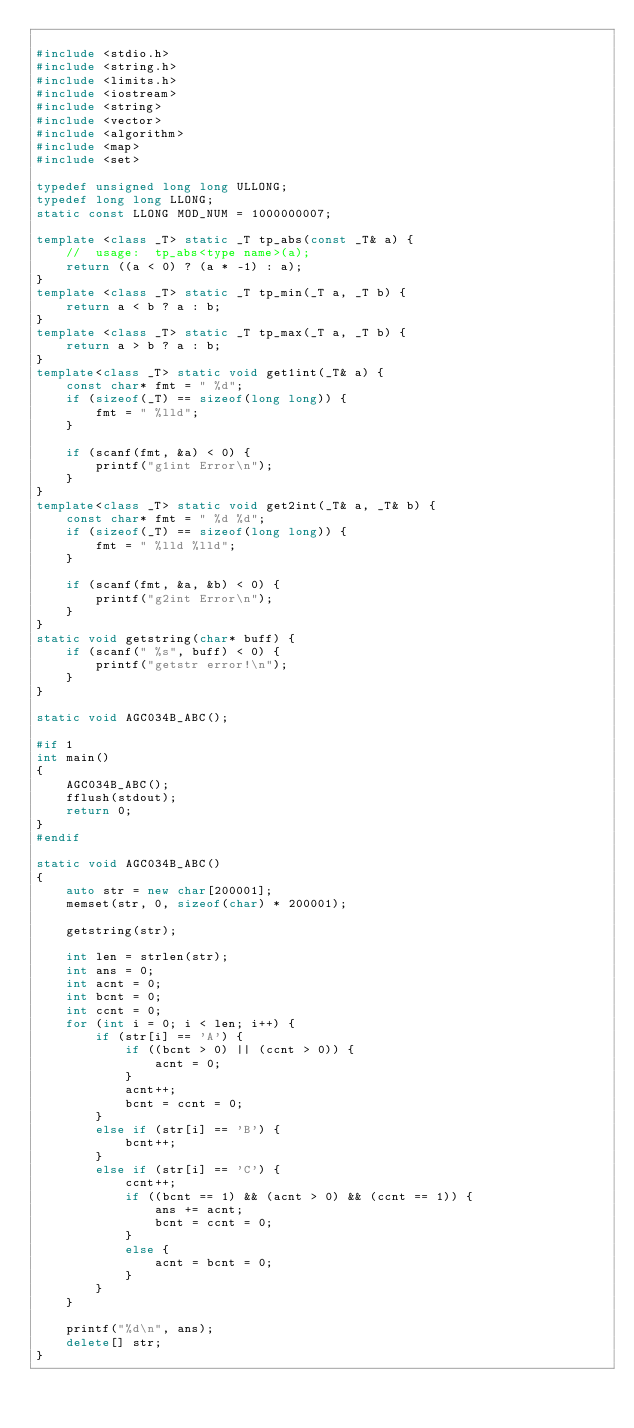<code> <loc_0><loc_0><loc_500><loc_500><_C++_>
#include <stdio.h>
#include <string.h>
#include <limits.h>
#include <iostream>
#include <string>
#include <vector>
#include <algorithm>
#include <map>
#include <set>

typedef unsigned long long ULLONG;
typedef long long LLONG;
static const LLONG MOD_NUM = 1000000007;

template <class _T> static _T tp_abs(const _T& a) {
	//	usage:  tp_abs<type name>(a);
	return ((a < 0) ? (a * -1) : a);
}
template <class _T> static _T tp_min(_T a, _T b) {
	return a < b ? a : b;
}
template <class _T> static _T tp_max(_T a, _T b) {
	return a > b ? a : b;
}
template<class _T> static void get1int(_T& a) {
	const char* fmt = " %d";
	if (sizeof(_T) == sizeof(long long)) {
		fmt = " %lld";
	}

	if (scanf(fmt, &a) < 0) {
		printf("g1int Error\n");
	}
}
template<class _T> static void get2int(_T& a, _T& b) {
	const char* fmt = " %d %d";
	if (sizeof(_T) == sizeof(long long)) {
		fmt = " %lld %lld";
	}

	if (scanf(fmt, &a, &b) < 0) {
		printf("g2int Error\n");
	}
}
static void getstring(char* buff) {
	if (scanf(" %s", buff) < 0) {
		printf("getstr error!\n");
	}
}

static void AGC034B_ABC();

#if 1
int main()
{
	AGC034B_ABC();
	fflush(stdout);
	return 0;
}
#endif

static void AGC034B_ABC()
{
	auto str = new char[200001];
	memset(str, 0, sizeof(char) * 200001);

	getstring(str);
	
	int len = strlen(str);
	int ans = 0;
	int acnt = 0;
	int bcnt = 0;
	int ccnt = 0;
	for (int i = 0; i < len; i++) {
		if (str[i] == 'A') {
			if ((bcnt > 0) || (ccnt > 0)) {
				acnt = 0;
			}
			acnt++;
			bcnt = ccnt = 0;
		}
		else if (str[i] == 'B') {
			bcnt++;
		}
		else if (str[i] == 'C') {
			ccnt++;
			if ((bcnt == 1) && (acnt > 0) && (ccnt == 1)) {
				ans += acnt;
				bcnt = ccnt = 0;
			}
			else {
				acnt = bcnt = 0;
			}
		}
	}

	printf("%d\n", ans);
	delete[] str;
}
</code> 